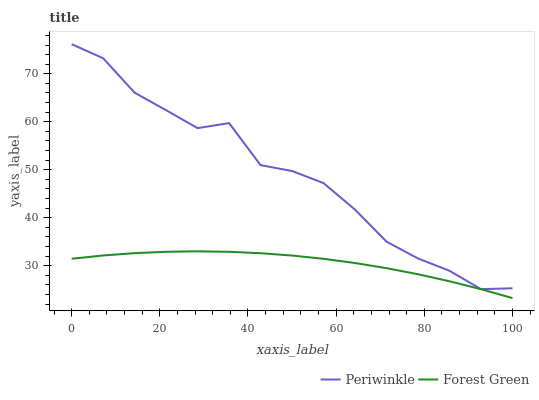Does Forest Green have the minimum area under the curve?
Answer yes or no. Yes. Does Periwinkle have the maximum area under the curve?
Answer yes or no. Yes. Does Periwinkle have the minimum area under the curve?
Answer yes or no. No. Is Forest Green the smoothest?
Answer yes or no. Yes. Is Periwinkle the roughest?
Answer yes or no. Yes. Is Periwinkle the smoothest?
Answer yes or no. No. Does Forest Green have the lowest value?
Answer yes or no. Yes. Does Periwinkle have the lowest value?
Answer yes or no. No. Does Periwinkle have the highest value?
Answer yes or no. Yes. Is Forest Green less than Periwinkle?
Answer yes or no. Yes. Is Periwinkle greater than Forest Green?
Answer yes or no. Yes. Does Forest Green intersect Periwinkle?
Answer yes or no. No. 